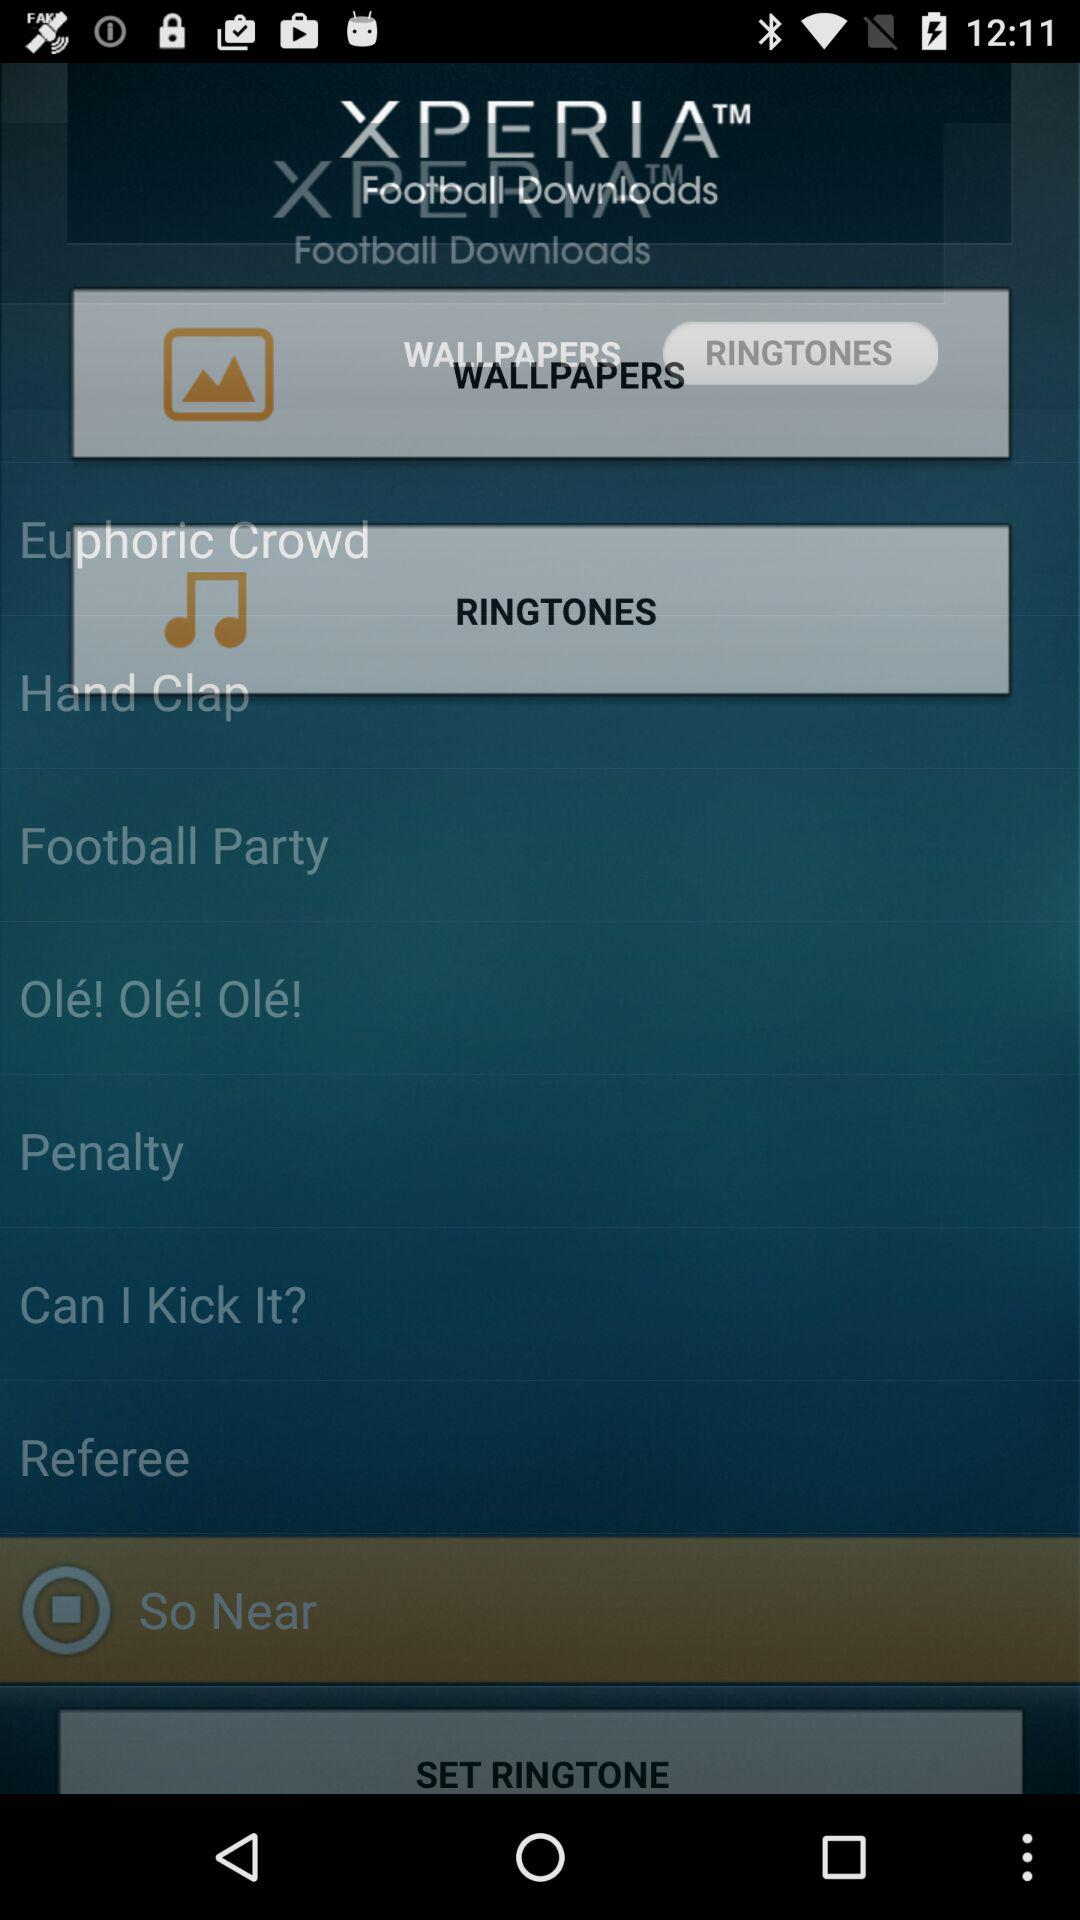What is the name of the application? The name of the application is "XPERIA". 